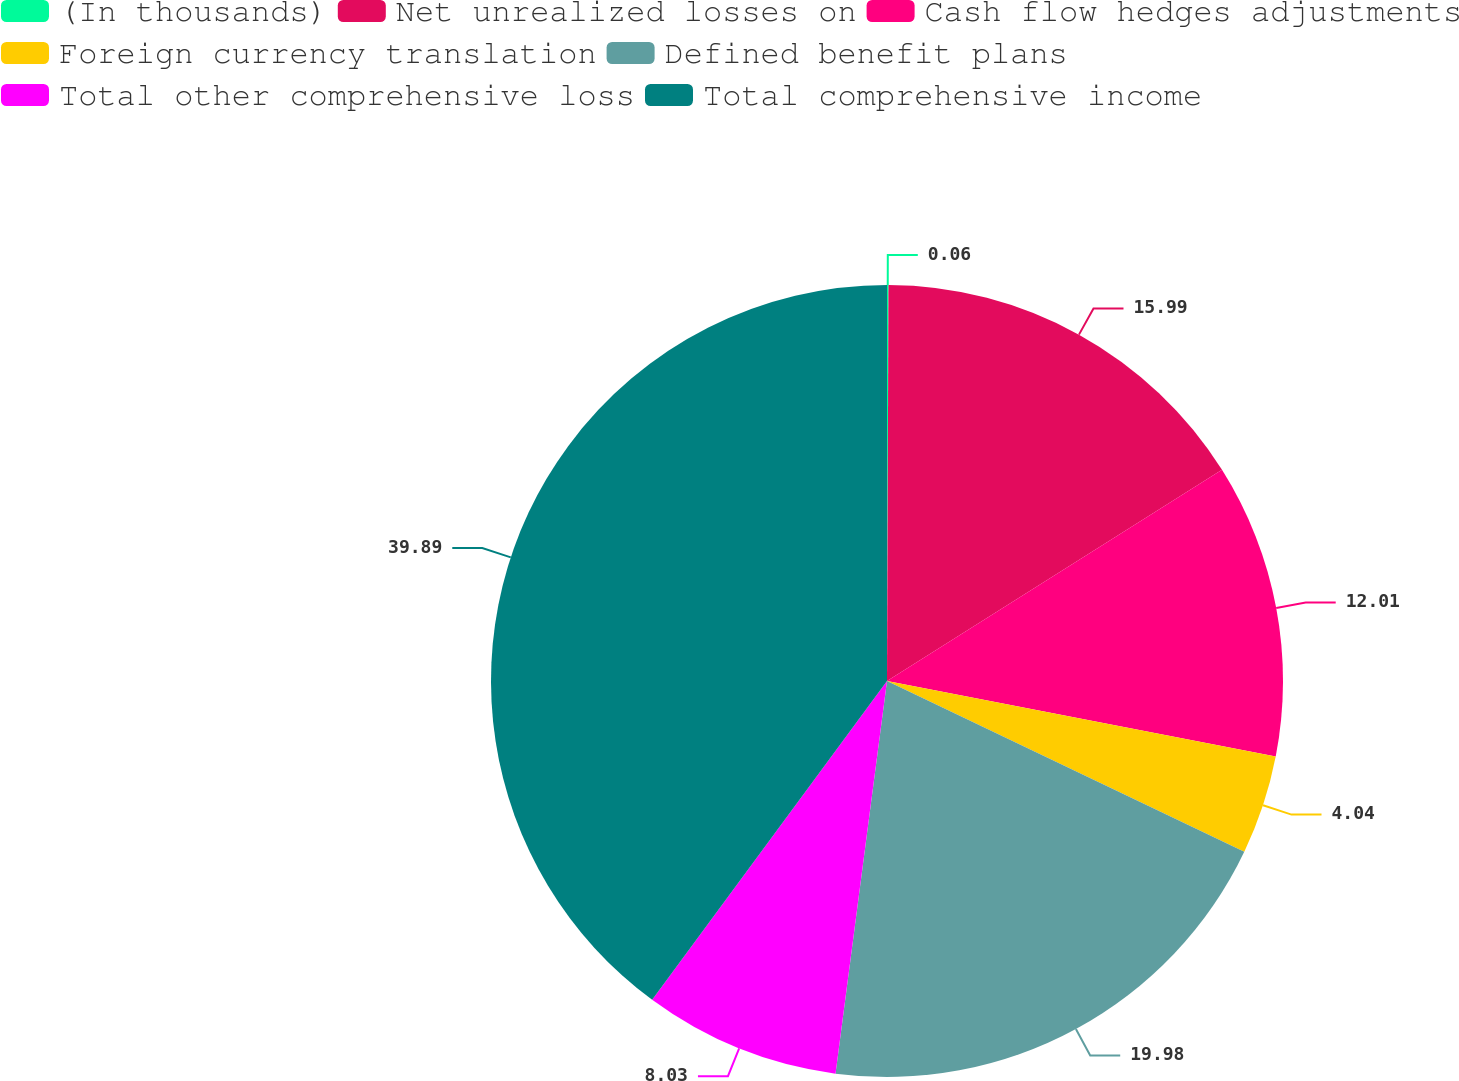<chart> <loc_0><loc_0><loc_500><loc_500><pie_chart><fcel>(In thousands)<fcel>Net unrealized losses on<fcel>Cash flow hedges adjustments<fcel>Foreign currency translation<fcel>Defined benefit plans<fcel>Total other comprehensive loss<fcel>Total comprehensive income<nl><fcel>0.06%<fcel>15.99%<fcel>12.01%<fcel>4.04%<fcel>19.98%<fcel>8.03%<fcel>39.9%<nl></chart> 